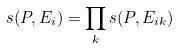<formula> <loc_0><loc_0><loc_500><loc_500>s ( P , E _ { i } ) = \prod _ { k } s ( P , E _ { i k } )</formula> 